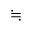Convert formula to latex. <formula><loc_0><loc_0><loc_500><loc_500>\ f a l l i n g d o t s e q</formula> 